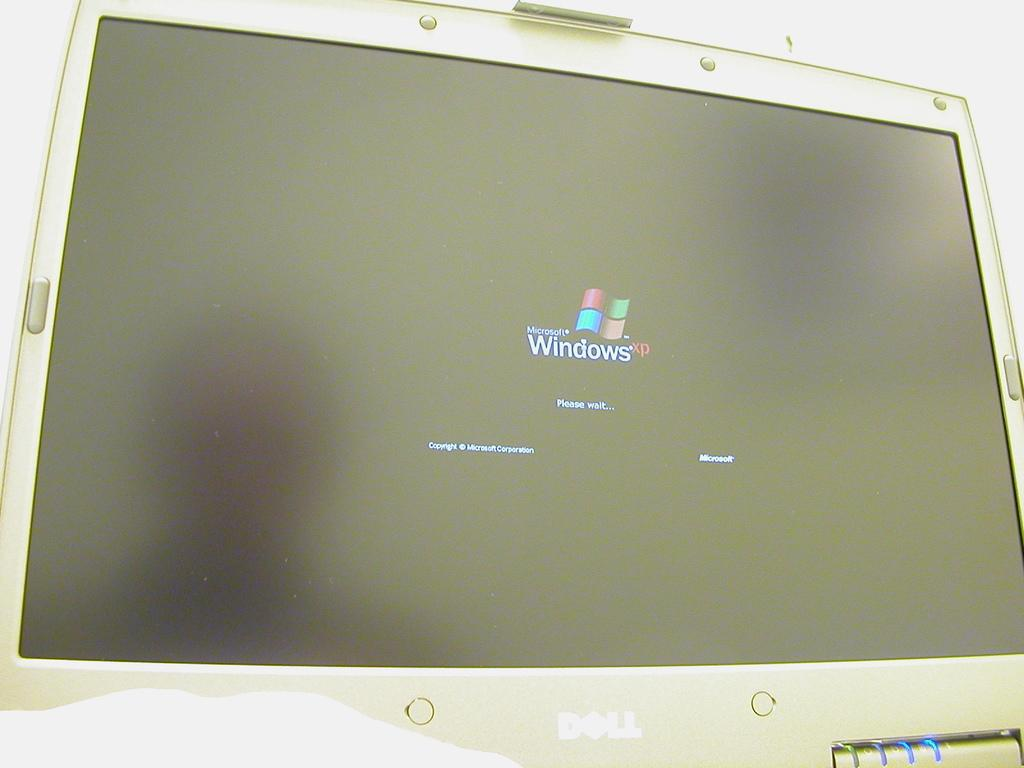<image>
Give a short and clear explanation of the subsequent image. A Dell laptop monitor is open to the Windows XP start-up page. 